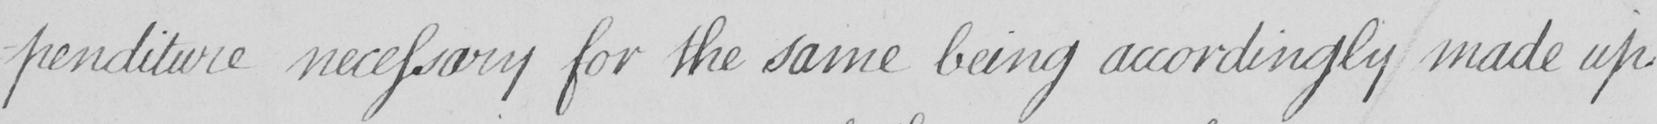What text is written in this handwritten line? -penditure necessary for the same being accordingly made up 